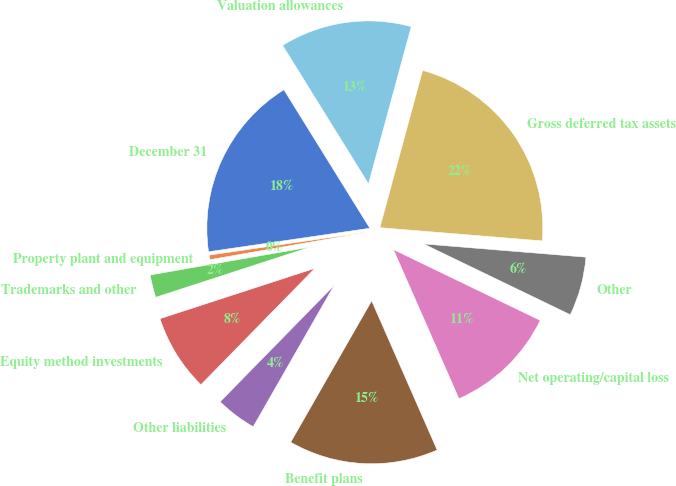<chart> <loc_0><loc_0><loc_500><loc_500><pie_chart><fcel>December 31<fcel>Property plant and equipment<fcel>Trademarks and other<fcel>Equity method investments<fcel>Other liabilities<fcel>Benefit plans<fcel>Net operating/capital loss<fcel>Other<fcel>Gross deferred tax assets<fcel>Valuation allowances<nl><fcel>18.47%<fcel>0.45%<fcel>2.25%<fcel>7.66%<fcel>4.06%<fcel>14.86%<fcel>11.26%<fcel>5.86%<fcel>22.07%<fcel>13.06%<nl></chart> 